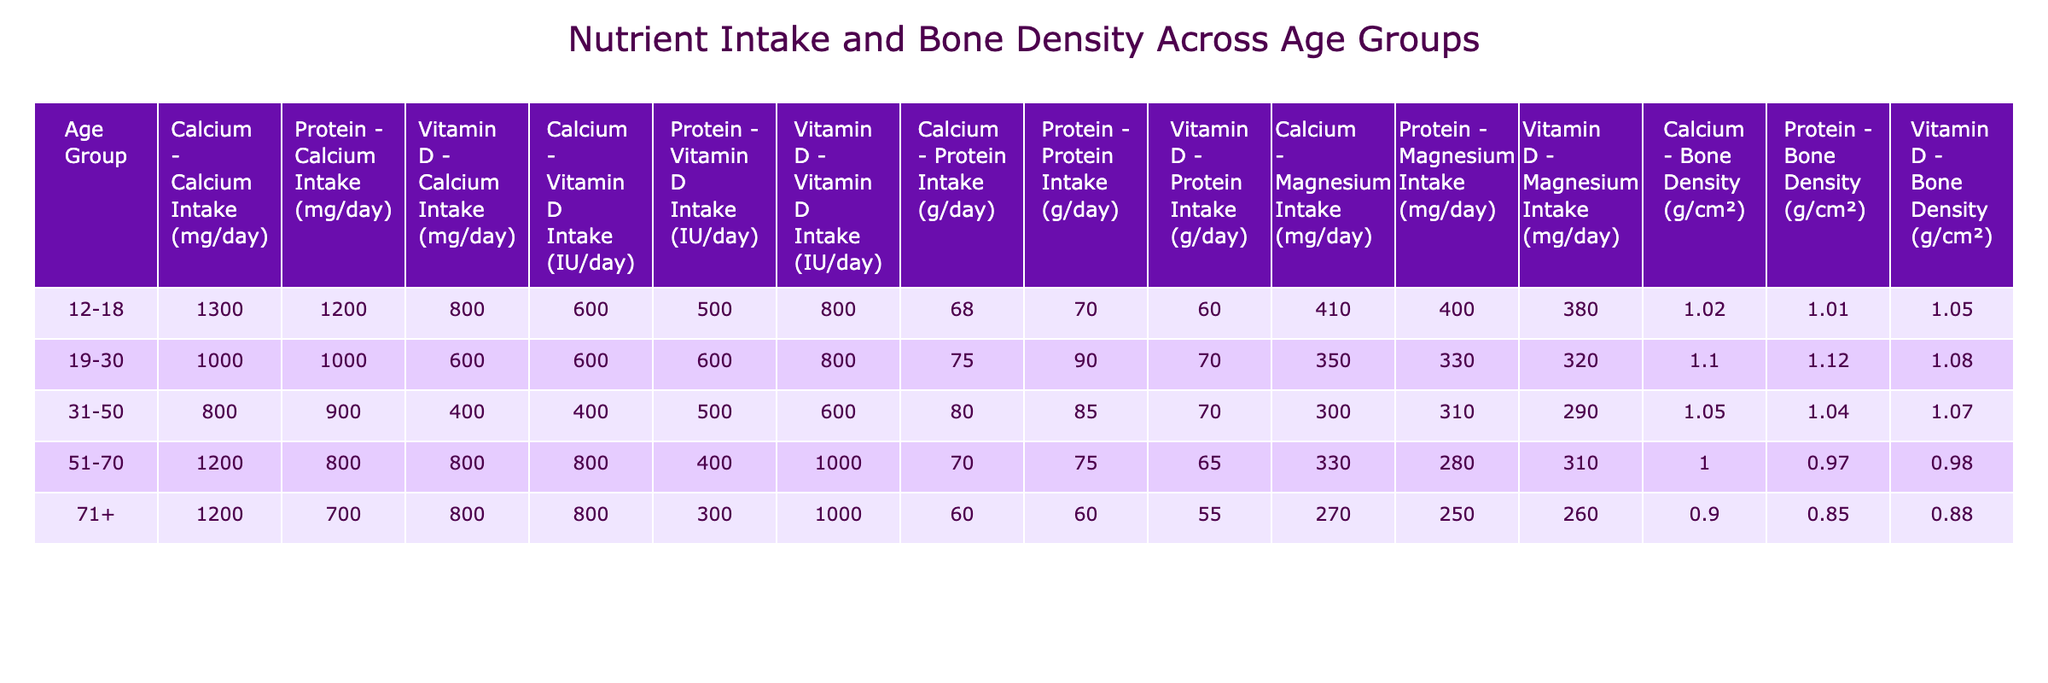What is the average calcium intake for the 31-50 age group? The calcium intakes in the 31-50 age group are 800 mg/day. Since there is only one entry, the average is simply 800 mg/day.
Answer: 800 mg/day Which age group has the highest protein intake? The protein intakes for each age group are as follows: 12-18 (70 g/day), 19-30 (90 g/day), 31-50 (85 g/day), 51-70 (75 g/day), and 71+ (60 g/day). The highest is 90 g/day for the 19-30 age group.
Answer: 19-30 Is the vitamin D intake for the 71+ age group higher than that of the 12-18 age group? The vitamin D intake for the 71+ age group is 800 IU/day, while it is 800 IU/day for the 12-18 age group. Since they are equal, the statement is false.
Answer: No What is the difference in bone density between the 19-30 age group and the 51-70 age group? The bone density for the 19-30 age group is 1.12 g/cm² and for the 51-70 age group is 0.97 g/cm². The difference is 1.12 - 0.97 = 0.15 g/cm².
Answer: 0.15 g/cm² Which nutrient has the highest intake in the 12-18 age group? The intakes for the 12-18 age group are Calcium (1300 mg/day), Vitamin D (800 IU/day), and Protein (1200 g/day). The highest intake is 1300 mg/day for Calcium.
Answer: Calcium Is the magnesium intake for the 51-70 age group lower than that for the 31-50 age group? The magnesium intake for the 51-70 age group is 280 mg/day while for the 31-50 age group it is 310 mg/day. Since 280 is lower than 310, the statement is true.
Answer: Yes What is the total protein intake for the 71+ age group? The protein intake for the 71+ age group is 700 g/day. There is only one entry for this age group, so the total is also 700 g/day.
Answer: 700 g/day Which age group shows the lowest bone density? The bone densities for each age group are as follows: 12-18 (1.02 g/cm²), 19-30 (1.10 g/cm²), 31-50 (1.05 g/cm²), 51-70 (0.97 g/cm²), and 71+ (0.85 g/cm²). The lowest is 0.85 g/cm² for the 71+ age group.
Answer: 71+ What was the average vitamin D intake across all age groups? The vitamin D intakes are: 800 IU/day (12-18), 600 IU/day (19-30), 400 IU/day (31-50), 800 IU/day (51-70), and 800 IU/day (71+). The total is 800 + 600 + 400 + 800 + 800 = 3400 IU/day, divided by 5 gives an average of 680 IU/day.
Answer: 680 IU/day Which nutrient is most consistently high across all age groups? By reviewing all nutrient intakes, we see that calcium and protein intake have notable values across most age groups, but only calcium (1200 mg/day) and protein (90 g/day) are high for the 19-30 age group while calcium remains high in several others. However, protein is consistently high as well. It's quite variable in 51-70 and 71+ years. Still, generally, protein intake stays significant.
Answer: Protein 